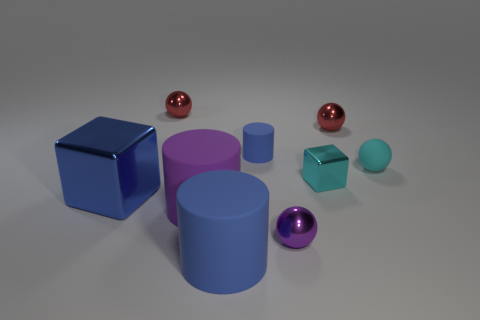What number of things are either things in front of the rubber ball or tiny red metallic balls that are to the left of the purple metal ball?
Offer a very short reply. 6. How many objects are either big purple objects or small red metal objects?
Your answer should be compact. 3. What is the size of the thing that is both behind the large metal block and in front of the tiny rubber ball?
Ensure brevity in your answer.  Small. What number of purple cylinders are the same material as the cyan cube?
Your response must be concise. 0. The large cube that is the same material as the small purple thing is what color?
Make the answer very short. Blue. Does the block that is on the right side of the purple cylinder have the same color as the matte ball?
Ensure brevity in your answer.  Yes. There is a red sphere to the right of the big purple thing; what is its material?
Your response must be concise. Metal. Are there an equal number of blue cylinders in front of the tiny blue matte cylinder and small blue cylinders?
Your answer should be compact. Yes. What number of big matte cylinders are the same color as the tiny rubber cylinder?
Give a very brief answer. 1. The tiny matte thing that is the same shape as the small purple metal thing is what color?
Offer a terse response. Cyan. 